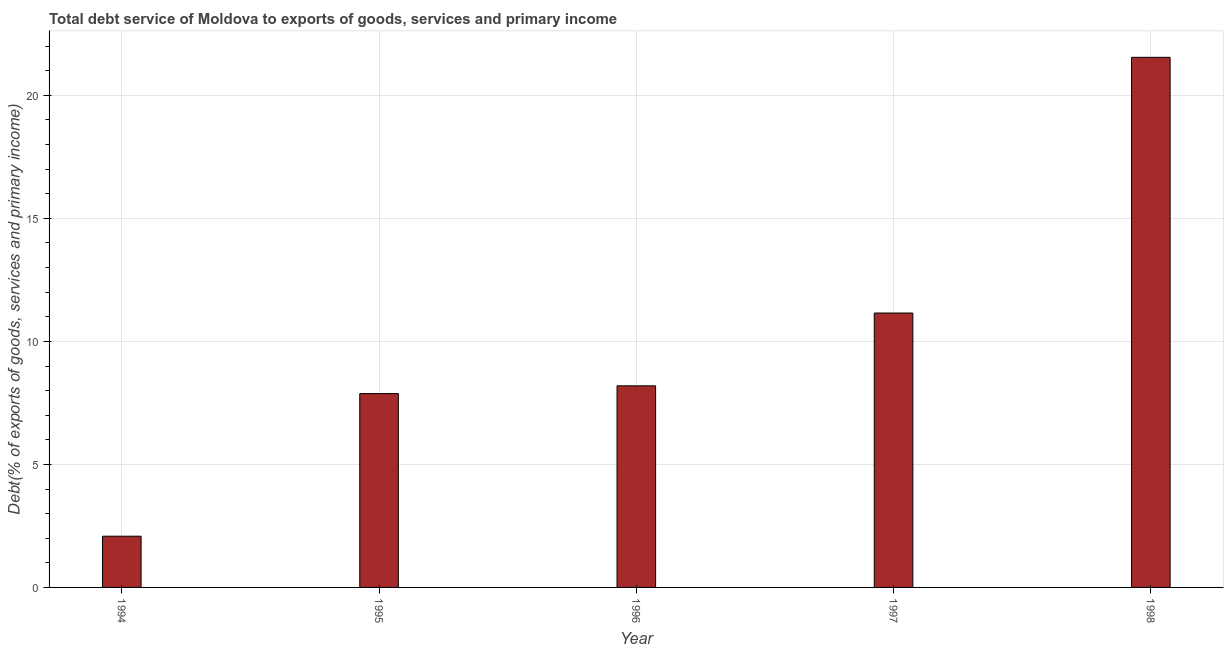Does the graph contain any zero values?
Your response must be concise. No. What is the title of the graph?
Your response must be concise. Total debt service of Moldova to exports of goods, services and primary income. What is the label or title of the X-axis?
Offer a very short reply. Year. What is the label or title of the Y-axis?
Make the answer very short. Debt(% of exports of goods, services and primary income). What is the total debt service in 1998?
Your response must be concise. 21.55. Across all years, what is the maximum total debt service?
Your response must be concise. 21.55. Across all years, what is the minimum total debt service?
Provide a succinct answer. 2.08. In which year was the total debt service minimum?
Offer a very short reply. 1994. What is the sum of the total debt service?
Your response must be concise. 50.86. What is the difference between the total debt service in 1996 and 1997?
Offer a very short reply. -2.96. What is the average total debt service per year?
Your answer should be very brief. 10.17. What is the median total debt service?
Offer a very short reply. 8.19. In how many years, is the total debt service greater than 18 %?
Offer a terse response. 1. What is the ratio of the total debt service in 1995 to that in 1997?
Offer a very short reply. 0.71. Is the total debt service in 1997 less than that in 1998?
Offer a terse response. Yes. What is the difference between the highest and the second highest total debt service?
Ensure brevity in your answer.  10.39. What is the difference between the highest and the lowest total debt service?
Your answer should be very brief. 19.46. In how many years, is the total debt service greater than the average total debt service taken over all years?
Your answer should be very brief. 2. What is the difference between two consecutive major ticks on the Y-axis?
Your answer should be very brief. 5. Are the values on the major ticks of Y-axis written in scientific E-notation?
Make the answer very short. No. What is the Debt(% of exports of goods, services and primary income) of 1994?
Provide a succinct answer. 2.08. What is the Debt(% of exports of goods, services and primary income) in 1995?
Keep it short and to the point. 7.88. What is the Debt(% of exports of goods, services and primary income) in 1996?
Ensure brevity in your answer.  8.19. What is the Debt(% of exports of goods, services and primary income) of 1997?
Offer a very short reply. 11.15. What is the Debt(% of exports of goods, services and primary income) of 1998?
Offer a terse response. 21.55. What is the difference between the Debt(% of exports of goods, services and primary income) in 1994 and 1995?
Provide a succinct answer. -5.8. What is the difference between the Debt(% of exports of goods, services and primary income) in 1994 and 1996?
Your answer should be very brief. -6.11. What is the difference between the Debt(% of exports of goods, services and primary income) in 1994 and 1997?
Your answer should be compact. -9.07. What is the difference between the Debt(% of exports of goods, services and primary income) in 1994 and 1998?
Your answer should be very brief. -19.46. What is the difference between the Debt(% of exports of goods, services and primary income) in 1995 and 1996?
Give a very brief answer. -0.31. What is the difference between the Debt(% of exports of goods, services and primary income) in 1995 and 1997?
Offer a very short reply. -3.27. What is the difference between the Debt(% of exports of goods, services and primary income) in 1995 and 1998?
Your answer should be very brief. -13.67. What is the difference between the Debt(% of exports of goods, services and primary income) in 1996 and 1997?
Your response must be concise. -2.96. What is the difference between the Debt(% of exports of goods, services and primary income) in 1996 and 1998?
Give a very brief answer. -13.35. What is the difference between the Debt(% of exports of goods, services and primary income) in 1997 and 1998?
Give a very brief answer. -10.39. What is the ratio of the Debt(% of exports of goods, services and primary income) in 1994 to that in 1995?
Keep it short and to the point. 0.26. What is the ratio of the Debt(% of exports of goods, services and primary income) in 1994 to that in 1996?
Provide a succinct answer. 0.25. What is the ratio of the Debt(% of exports of goods, services and primary income) in 1994 to that in 1997?
Offer a terse response. 0.19. What is the ratio of the Debt(% of exports of goods, services and primary income) in 1994 to that in 1998?
Provide a succinct answer. 0.1. What is the ratio of the Debt(% of exports of goods, services and primary income) in 1995 to that in 1997?
Your answer should be compact. 0.71. What is the ratio of the Debt(% of exports of goods, services and primary income) in 1995 to that in 1998?
Make the answer very short. 0.37. What is the ratio of the Debt(% of exports of goods, services and primary income) in 1996 to that in 1997?
Provide a short and direct response. 0.73. What is the ratio of the Debt(% of exports of goods, services and primary income) in 1996 to that in 1998?
Your response must be concise. 0.38. What is the ratio of the Debt(% of exports of goods, services and primary income) in 1997 to that in 1998?
Provide a succinct answer. 0.52. 